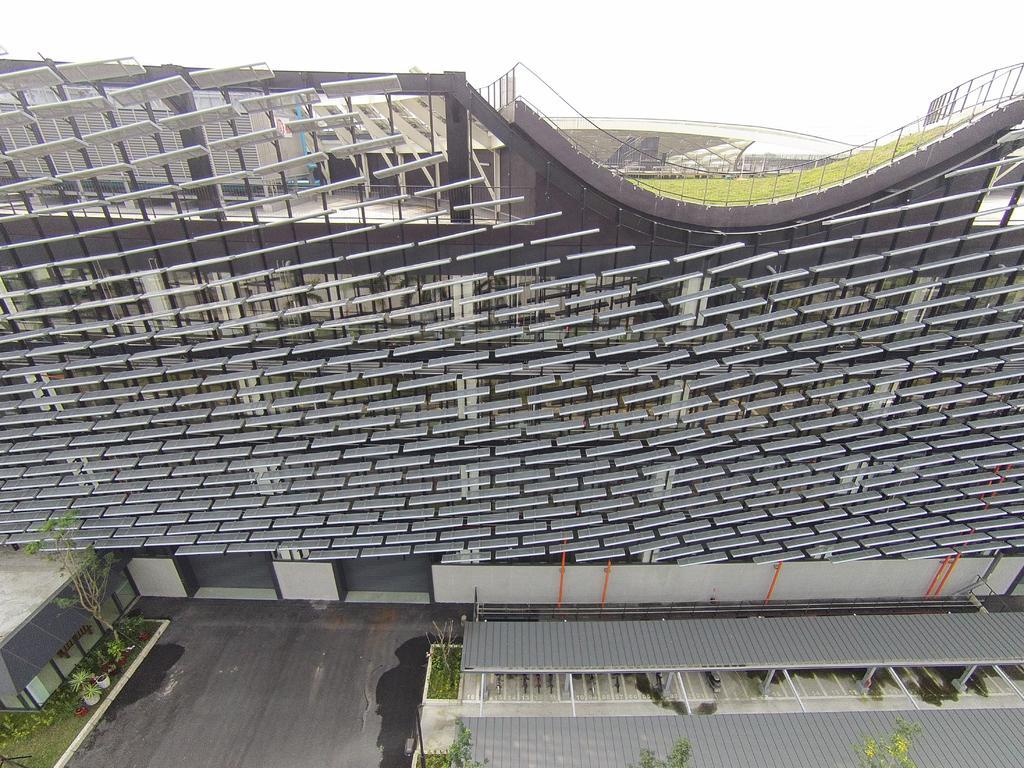Could you give a brief overview of what you see in this image? In this image, I can see an architecture building. At the bottom of the image, I can see the trees, flower pots, grass and sheds. In the background, there is the sky. 